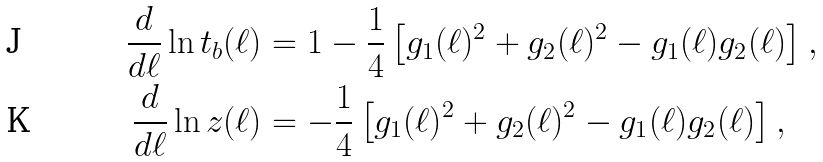<formula> <loc_0><loc_0><loc_500><loc_500>\frac { d } { d \ell } \ln t _ { b } ( \ell ) & = 1 - \frac { 1 } { 4 } \left [ g _ { 1 } ( \ell ) ^ { 2 } + g _ { 2 } ( \ell ) ^ { 2 } - g _ { 1 } ( \ell ) g _ { 2 } ( \ell ) \right ] , \\ \frac { d } { d \ell } \ln z ( \ell ) & = - \frac { 1 } { 4 } \left [ g _ { 1 } ( \ell ) ^ { 2 } + g _ { 2 } ( \ell ) ^ { 2 } - g _ { 1 } ( \ell ) g _ { 2 } ( \ell ) \right ] ,</formula> 